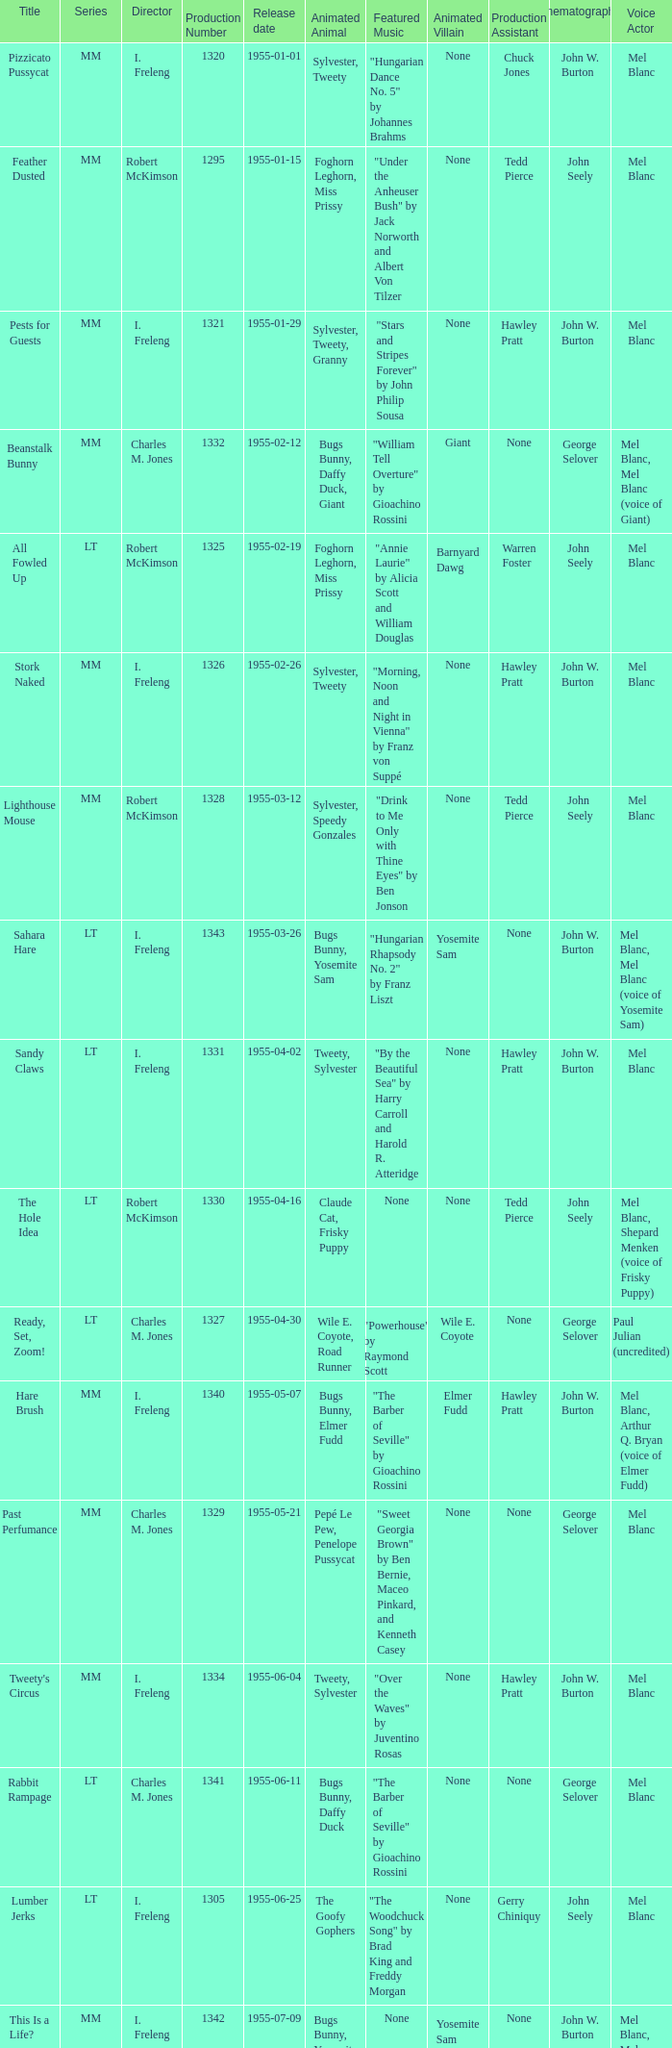What is the release date of production number 1327? 1955-04-30. 